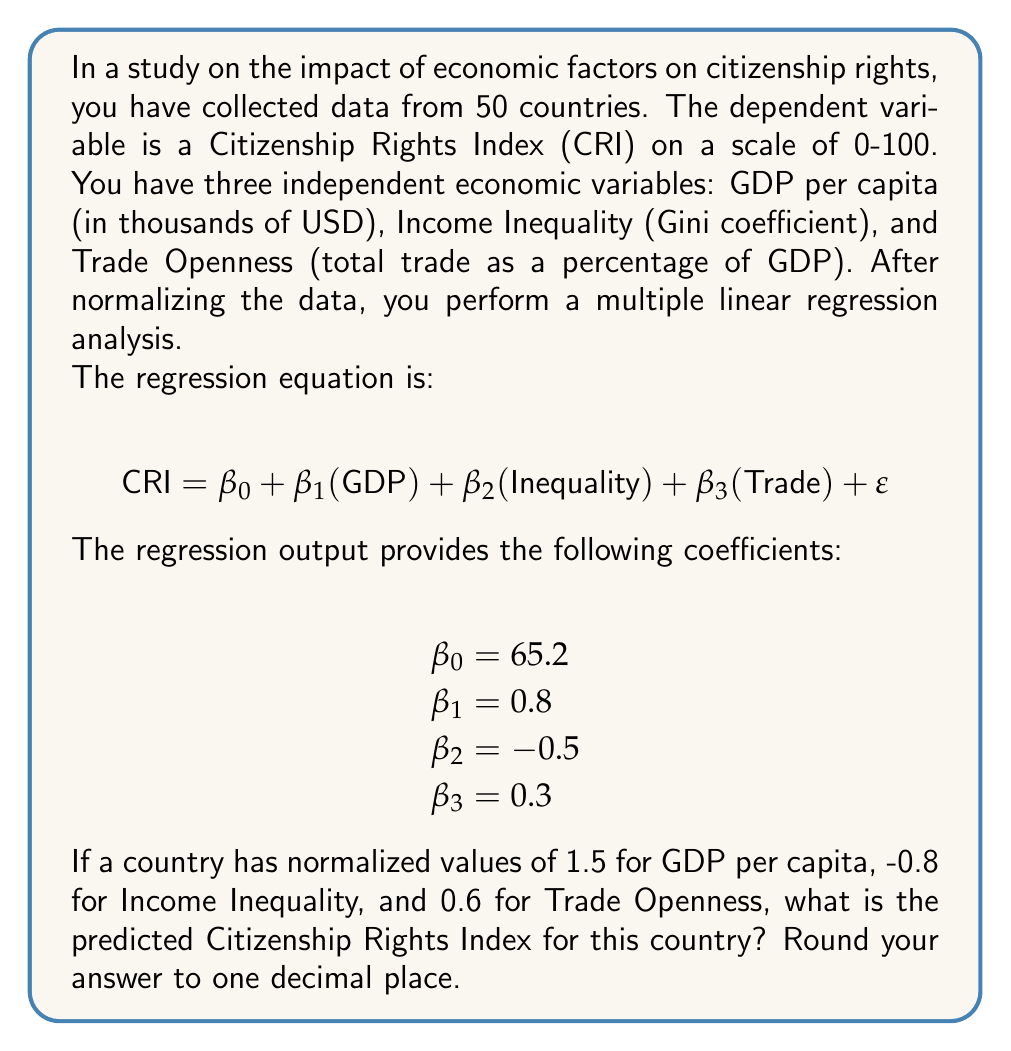Can you solve this math problem? To solve this problem, we need to follow these steps:

1. Understand the multiple linear regression equation:
   The equation $\text{CRI} = \beta_0 + \beta_1(\text{GDP}) + \beta_2(\text{Inequality}) + \beta_3(\text{Trade}) + \varepsilon$ represents the relationship between the Citizenship Rights Index and the economic factors.

2. Identify the given values:
   - $\beta_0 = 65.2$ (intercept)
   - $\beta_1 = 0.8$ (coefficient for GDP)
   - $\beta_2 = -0.5$ (coefficient for Inequality)
   - $\beta_3 = 0.3$ (coefficient for Trade)
   - GDP normalized value = 1.5
   - Inequality normalized value = -0.8
   - Trade normalized value = 0.6

3. Substitute these values into the equation:
   $$ \text{CRI} = 65.2 + 0.8(1.5) + (-0.5)(-0.8) + 0.3(0.6) $$

4. Calculate each term:
   - $65.2$ (intercept)
   - $0.8 \times 1.5 = 1.2$ (GDP term)
   - $(-0.5) \times (-0.8) = 0.4$ (Inequality term)
   - $0.3 \times 0.6 = 0.18$ (Trade term)

5. Sum up all terms:
   $$ \text{CRI} = 65.2 + 1.2 + 0.4 + 0.18 = 66.98 $$

6. Round the result to one decimal place:
   $$ \text{CRI} \approx 67.0 $$
Answer: 67.0 